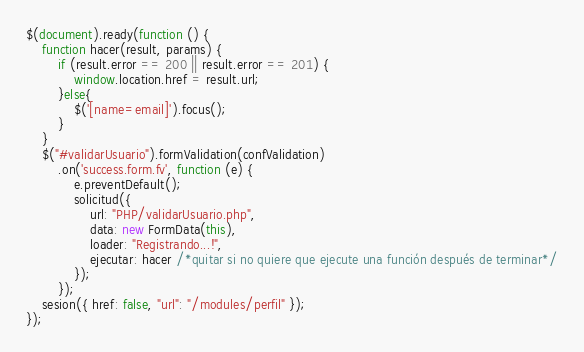<code> <loc_0><loc_0><loc_500><loc_500><_JavaScript_>$(document).ready(function () {
    function hacer(result, params) {
        if (result.error == 200 || result.error == 201) {
            window.location.href = result.url;
        }else{
            $('[name=email]').focus();
        }
    }
    $("#validarUsuario").formValidation(confValidation)
        .on('success.form.fv', function (e) {
            e.preventDefault();
            solicitud({
                url: "PHP/validarUsuario.php",
                data: new FormData(this),
                loader: "Registrando...!",
                ejecutar: hacer /*quitar si no quiere que ejecute una función después de terminar*/
            });
        });
    sesion({ href: false, "url": "/modules/perfil" });
});
</code> 